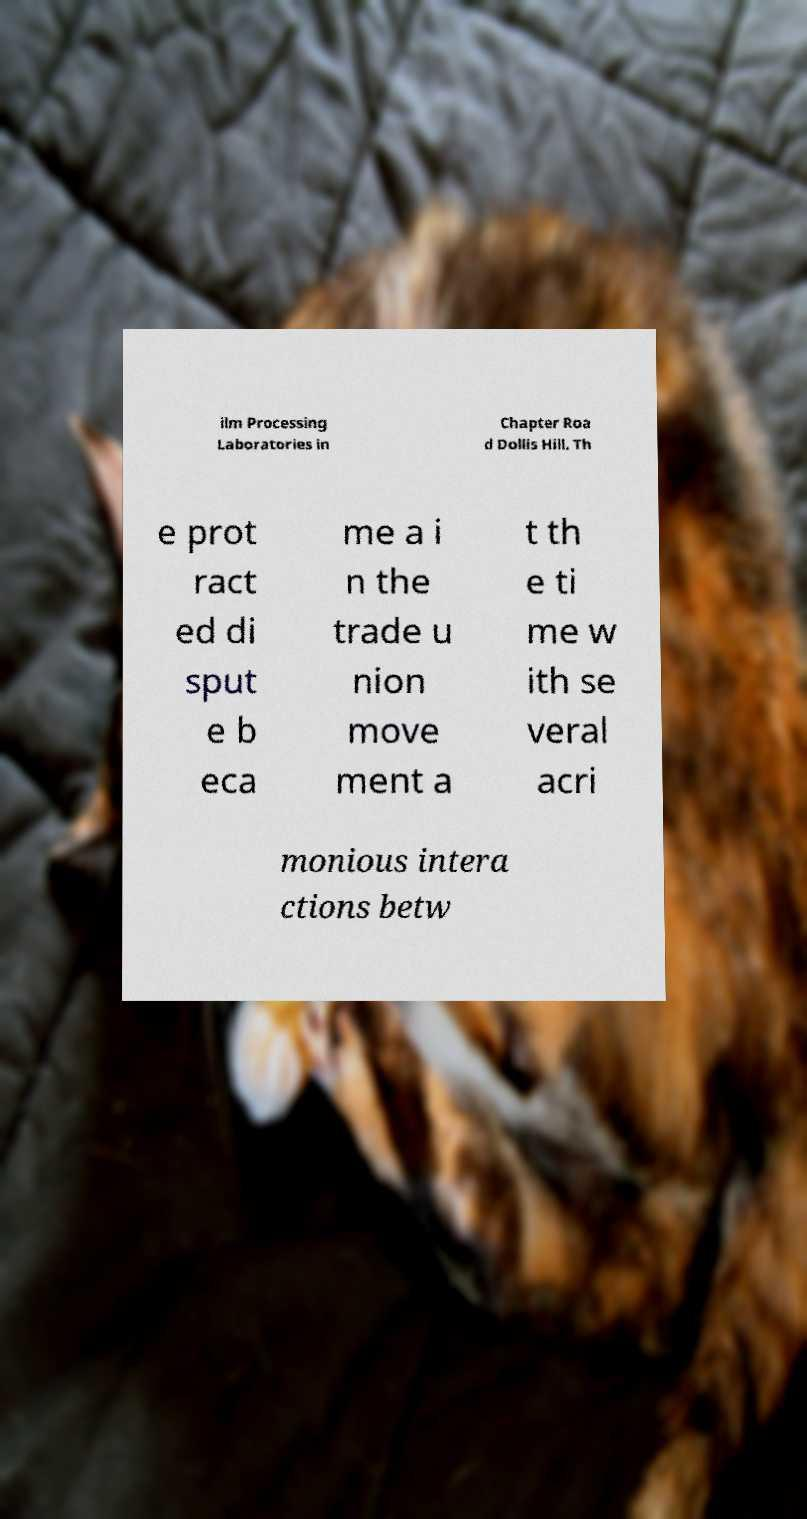Please identify and transcribe the text found in this image. ilm Processing Laboratories in Chapter Roa d Dollis Hill. Th e prot ract ed di sput e b eca me a i n the trade u nion move ment a t th e ti me w ith se veral acri monious intera ctions betw 